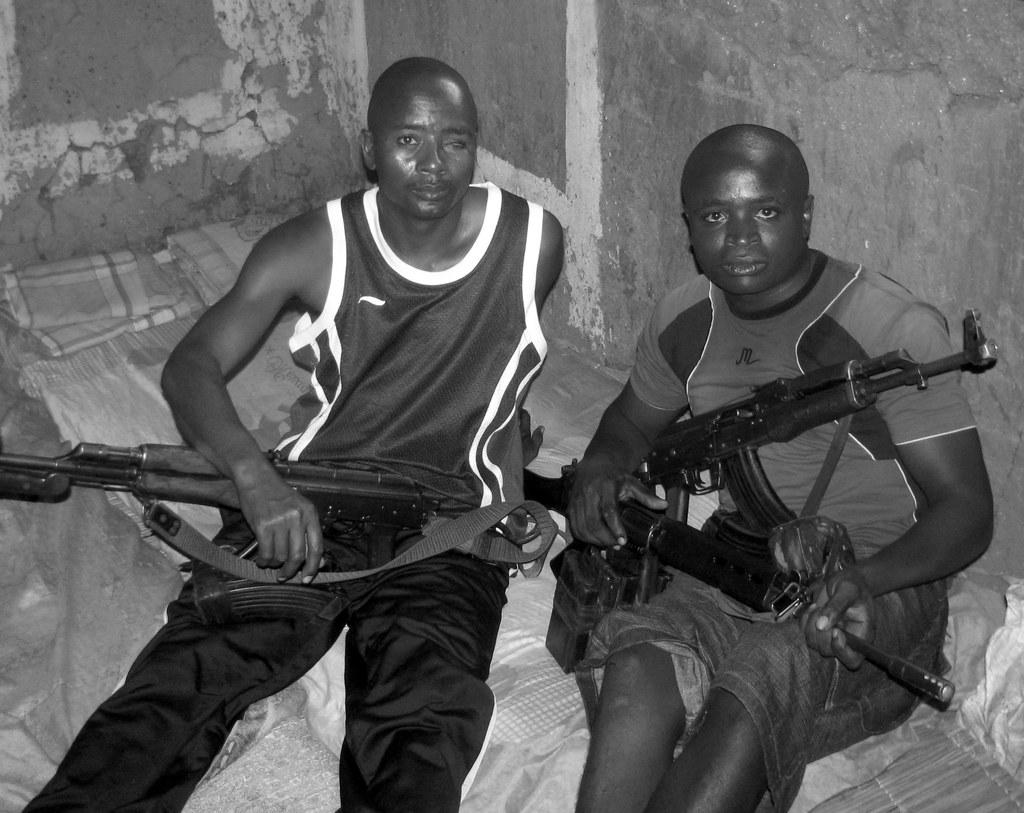How many people are in the image? There are two persons in the image. What are the persons doing in the image? The persons are sitting down and holding guns in their hands. What can be seen in the background of the image? There are blankets and a wall in the background of the image. What year is depicted in the image? The image does not depict a specific year; it is a photograph of two persons sitting down and holding guns. How many frogs can be seen in the image? There are no frogs present in the image. 